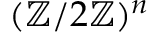<formula> <loc_0><loc_0><loc_500><loc_500>( \mathbb { Z } / 2 \mathbb { Z } ) ^ { n }</formula> 